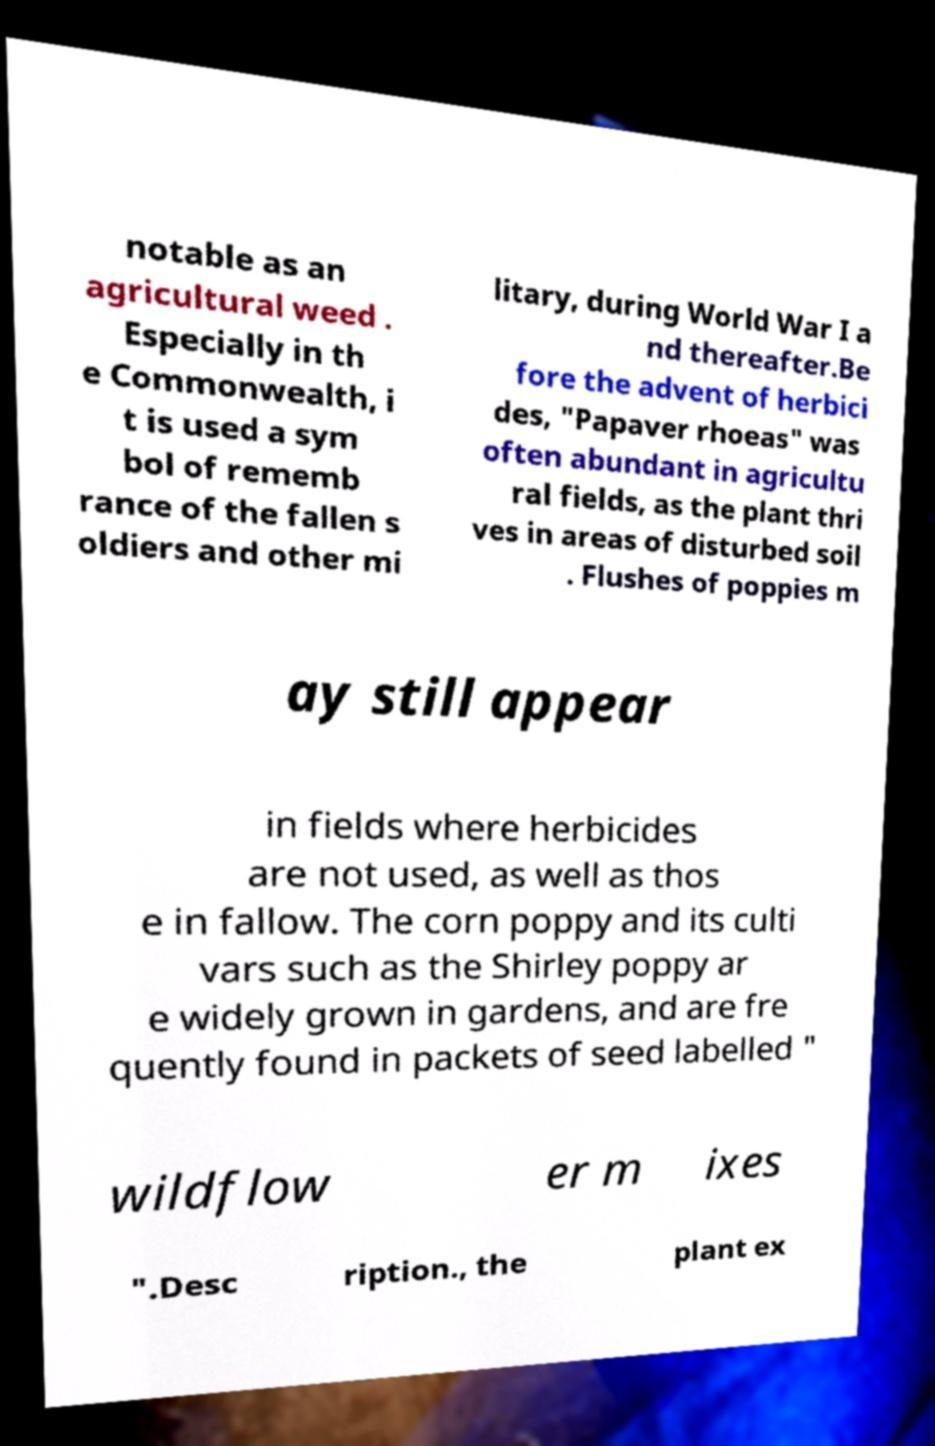What messages or text are displayed in this image? I need them in a readable, typed format. notable as an agricultural weed . Especially in th e Commonwealth, i t is used a sym bol of rememb rance of the fallen s oldiers and other mi litary, during World War I a nd thereafter.Be fore the advent of herbici des, "Papaver rhoeas" was often abundant in agricultu ral fields, as the plant thri ves in areas of disturbed soil . Flushes of poppies m ay still appear in fields where herbicides are not used, as well as thos e in fallow. The corn poppy and its culti vars such as the Shirley poppy ar e widely grown in gardens, and are fre quently found in packets of seed labelled " wildflow er m ixes ".Desc ription., the plant ex 